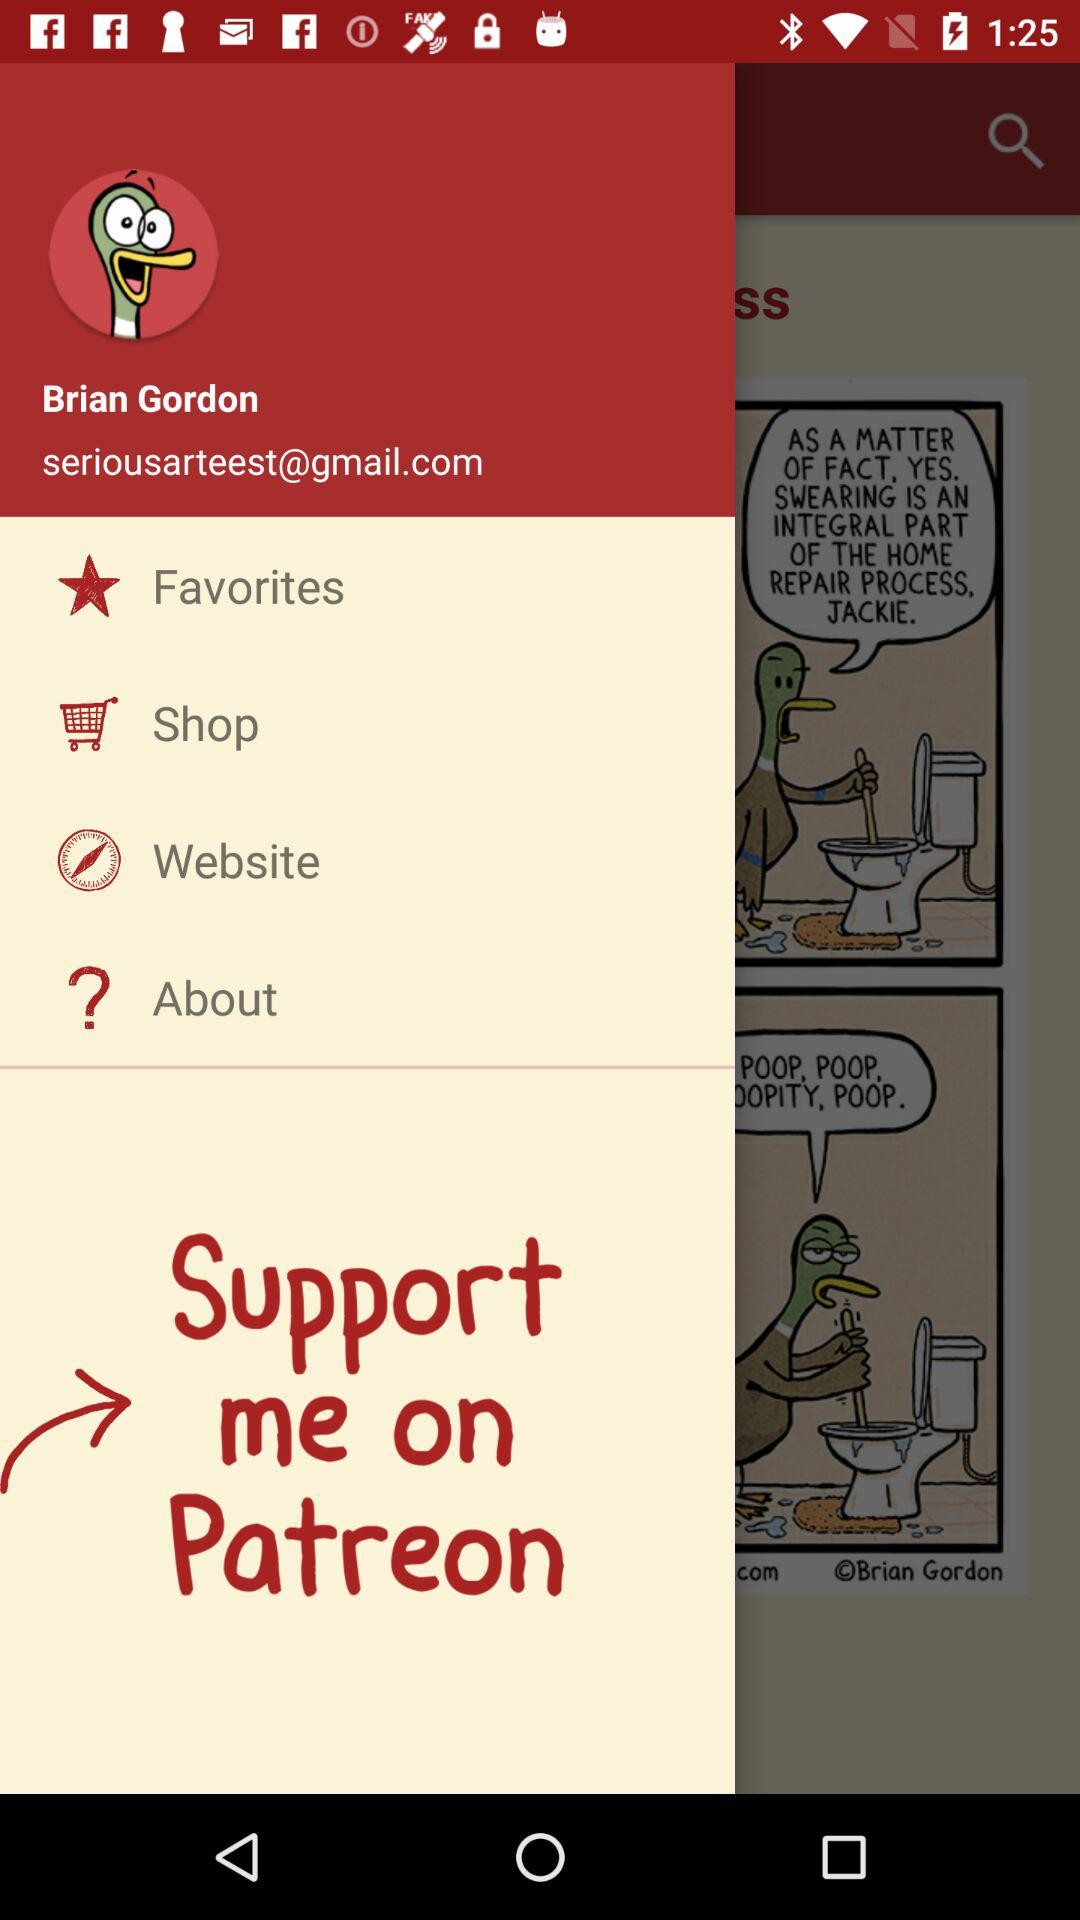What is the email address? The email address is seriousarteest@gmail.com. 